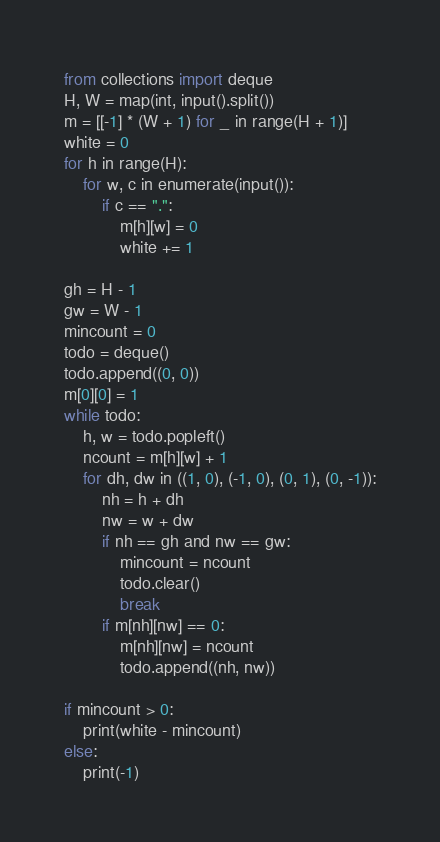Convert code to text. <code><loc_0><loc_0><loc_500><loc_500><_Python_>from collections import deque
H, W = map(int, input().split())
m = [[-1] * (W + 1) for _ in range(H + 1)]
white = 0
for h in range(H):
    for w, c in enumerate(input()):
        if c == ".":
            m[h][w] = 0
            white += 1

gh = H - 1
gw = W - 1
mincount = 0
todo = deque()
todo.append((0, 0))
m[0][0] = 1
while todo:
    h, w = todo.popleft()
    ncount = m[h][w] + 1
    for dh, dw in ((1, 0), (-1, 0), (0, 1), (0, -1)):
        nh = h + dh
        nw = w + dw
        if nh == gh and nw == gw:
            mincount = ncount
            todo.clear()
            break
        if m[nh][nw] == 0:
            m[nh][nw] = ncount
            todo.append((nh, nw))

if mincount > 0:
    print(white - mincount)
else:
    print(-1)
</code> 